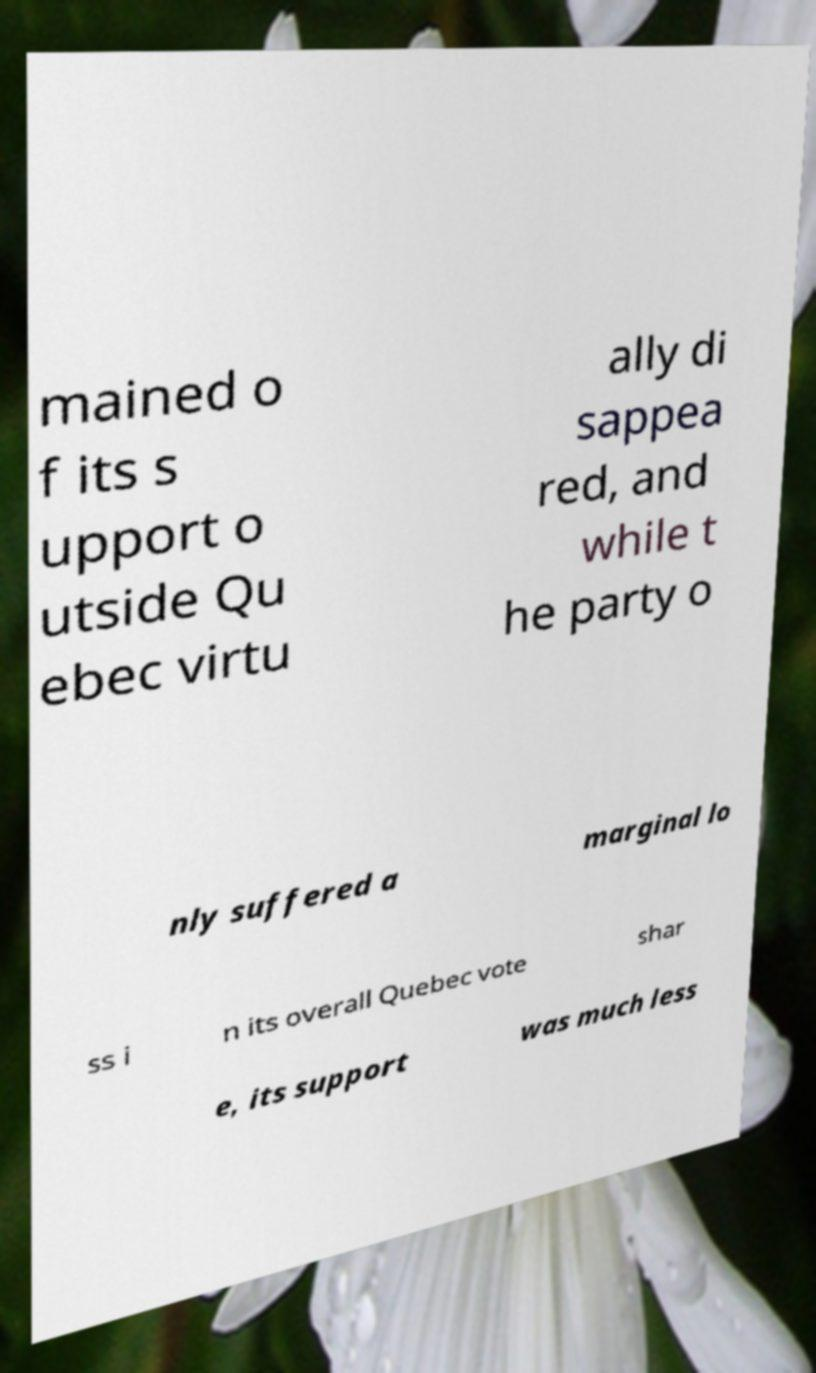Please identify and transcribe the text found in this image. mained o f its s upport o utside Qu ebec virtu ally di sappea red, and while t he party o nly suffered a marginal lo ss i n its overall Quebec vote shar e, its support was much less 